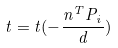Convert formula to latex. <formula><loc_0><loc_0><loc_500><loc_500>t = t ( - \frac { n ^ { T } P _ { i } } { d } )</formula> 